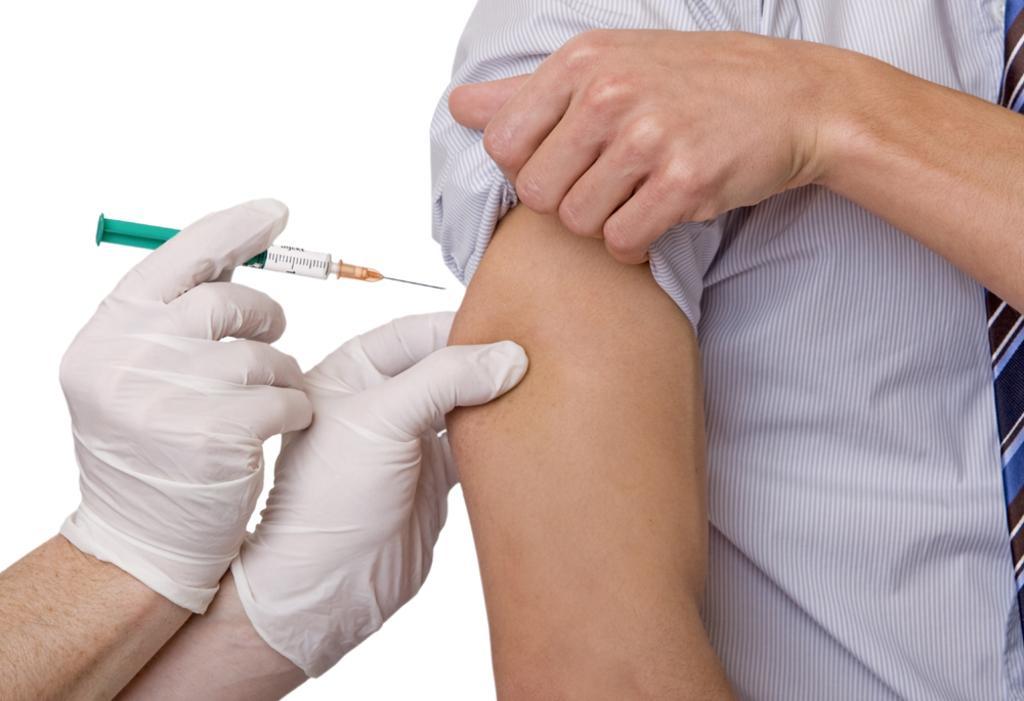Please provide a concise description of this image. In the image there is a hand with gloves injecting a syringe to a man on his hand. 